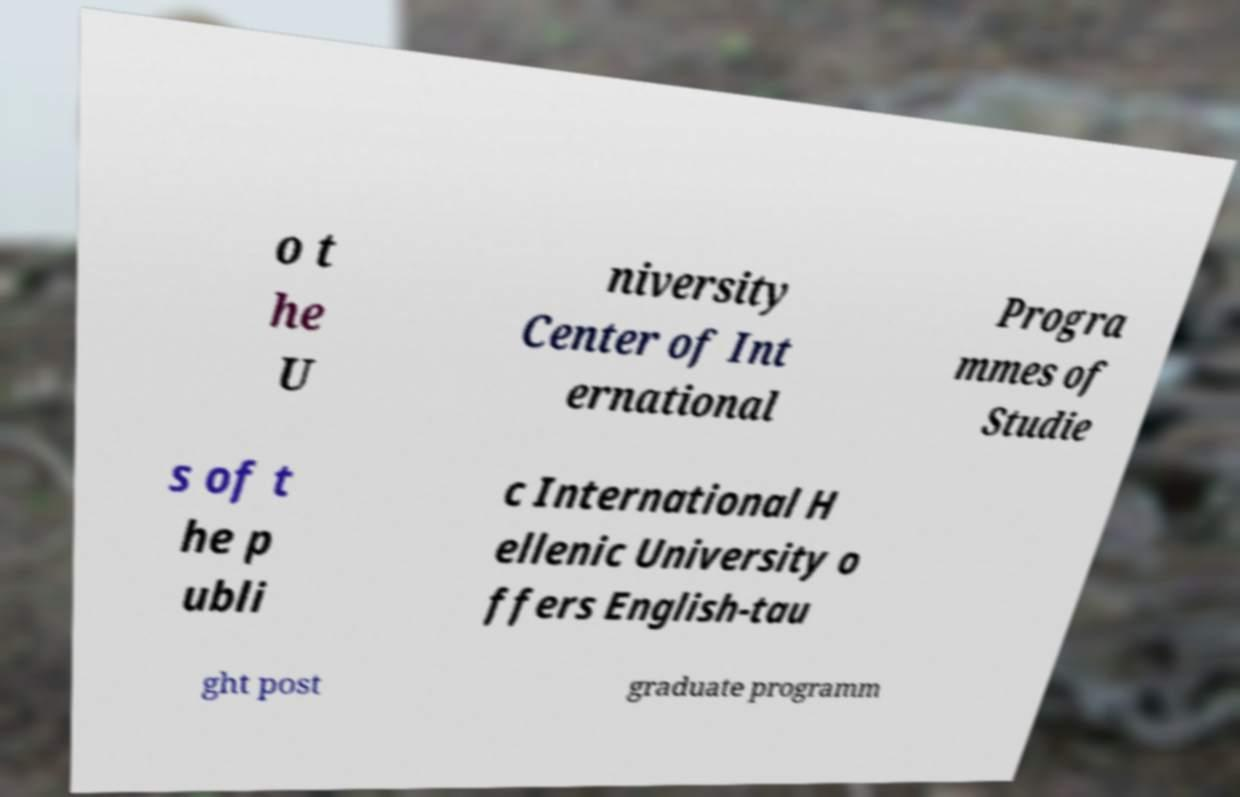For documentation purposes, I need the text within this image transcribed. Could you provide that? o t he U niversity Center of Int ernational Progra mmes of Studie s of t he p ubli c International H ellenic University o ffers English-tau ght post graduate programm 